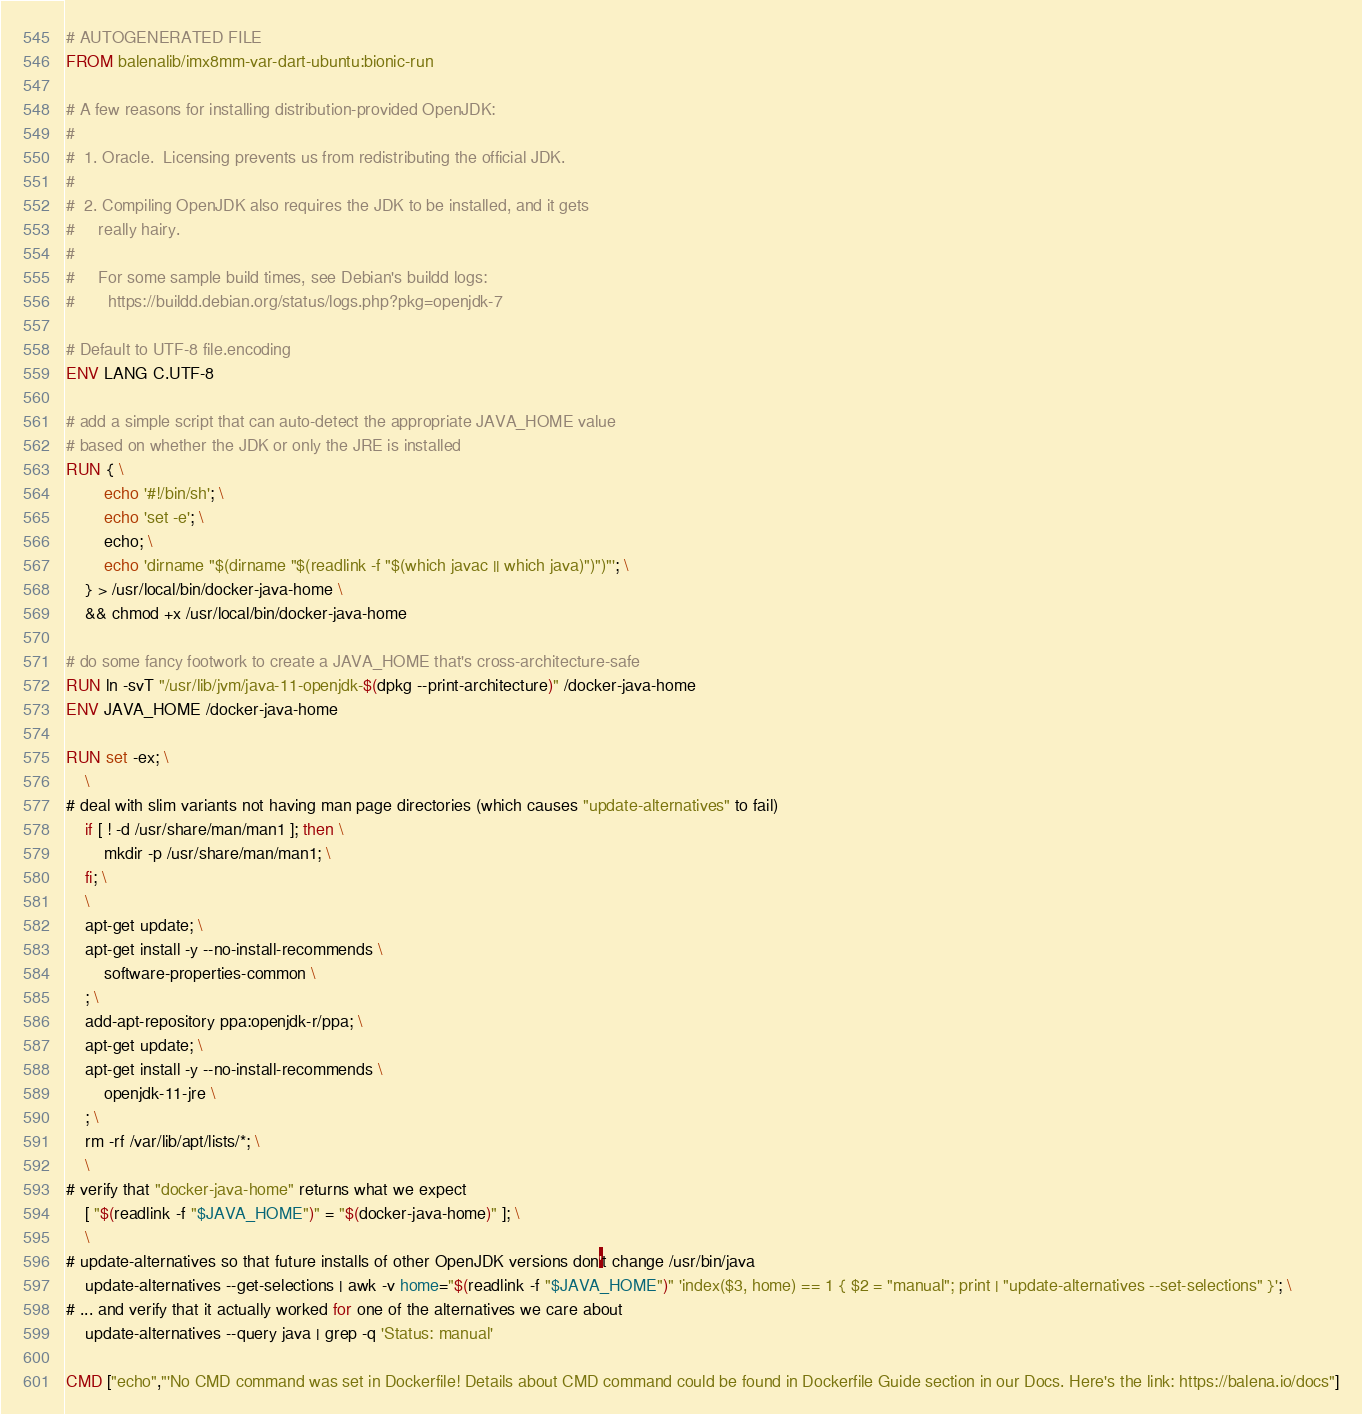<code> <loc_0><loc_0><loc_500><loc_500><_Dockerfile_># AUTOGENERATED FILE
FROM balenalib/imx8mm-var-dart-ubuntu:bionic-run

# A few reasons for installing distribution-provided OpenJDK:
#
#  1. Oracle.  Licensing prevents us from redistributing the official JDK.
#
#  2. Compiling OpenJDK also requires the JDK to be installed, and it gets
#     really hairy.
#
#     For some sample build times, see Debian's buildd logs:
#       https://buildd.debian.org/status/logs.php?pkg=openjdk-7

# Default to UTF-8 file.encoding
ENV LANG C.UTF-8

# add a simple script that can auto-detect the appropriate JAVA_HOME value
# based on whether the JDK or only the JRE is installed
RUN { \
		echo '#!/bin/sh'; \
		echo 'set -e'; \
		echo; \
		echo 'dirname "$(dirname "$(readlink -f "$(which javac || which java)")")"'; \
	} > /usr/local/bin/docker-java-home \
	&& chmod +x /usr/local/bin/docker-java-home

# do some fancy footwork to create a JAVA_HOME that's cross-architecture-safe
RUN ln -svT "/usr/lib/jvm/java-11-openjdk-$(dpkg --print-architecture)" /docker-java-home
ENV JAVA_HOME /docker-java-home

RUN set -ex; \
	\
# deal with slim variants not having man page directories (which causes "update-alternatives" to fail)
	if [ ! -d /usr/share/man/man1 ]; then \
		mkdir -p /usr/share/man/man1; \
	fi; \
	\
	apt-get update; \
	apt-get install -y --no-install-recommends \
		software-properties-common \
	; \
	add-apt-repository ppa:openjdk-r/ppa; \
	apt-get update; \
	apt-get install -y --no-install-recommends \
		openjdk-11-jre \
	; \
	rm -rf /var/lib/apt/lists/*; \
	\
# verify that "docker-java-home" returns what we expect
	[ "$(readlink -f "$JAVA_HOME")" = "$(docker-java-home)" ]; \
	\
# update-alternatives so that future installs of other OpenJDK versions don't change /usr/bin/java
	update-alternatives --get-selections | awk -v home="$(readlink -f "$JAVA_HOME")" 'index($3, home) == 1 { $2 = "manual"; print | "update-alternatives --set-selections" }'; \
# ... and verify that it actually worked for one of the alternatives we care about
	update-alternatives --query java | grep -q 'Status: manual'

CMD ["echo","'No CMD command was set in Dockerfile! Details about CMD command could be found in Dockerfile Guide section in our Docs. Here's the link: https://balena.io/docs"]
</code> 